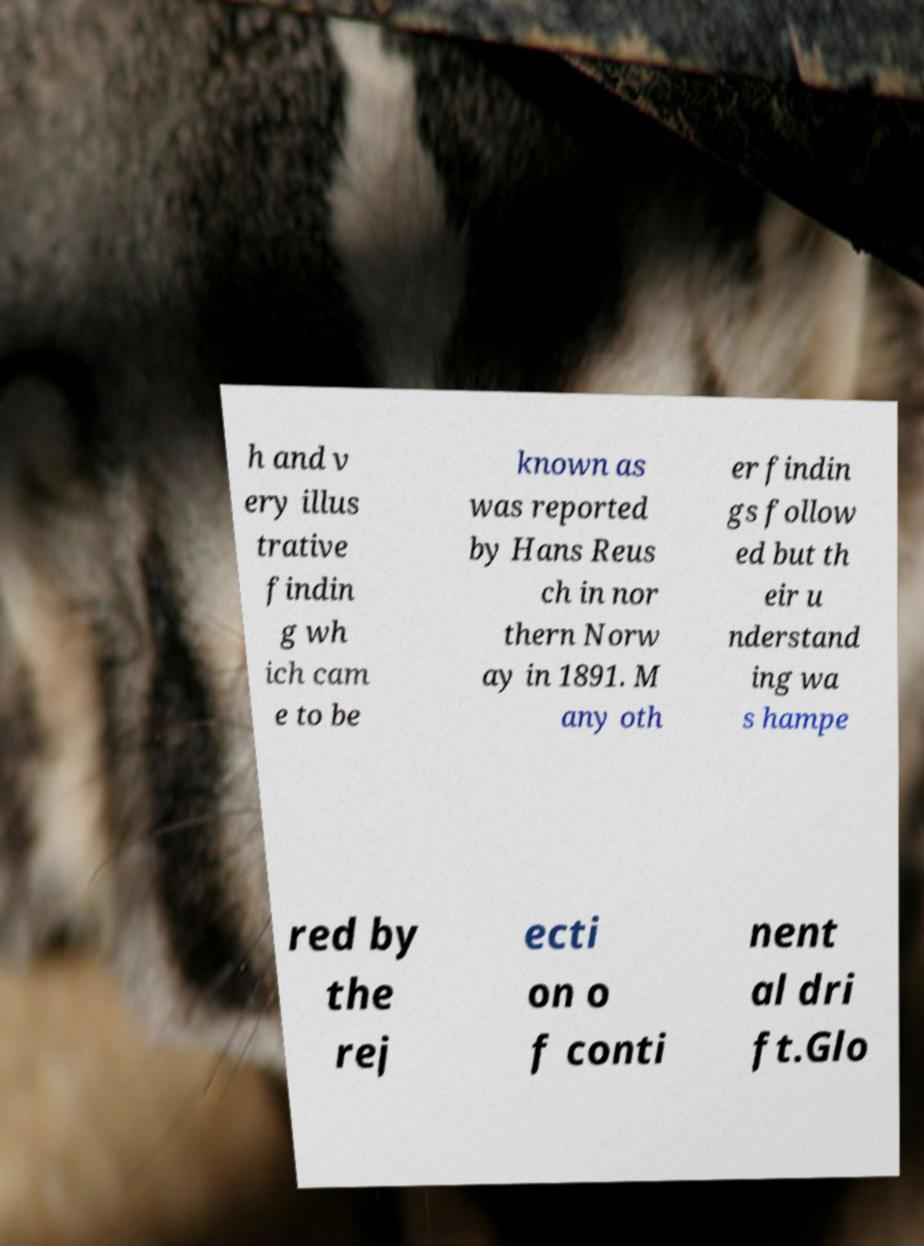Could you extract and type out the text from this image? h and v ery illus trative findin g wh ich cam e to be known as was reported by Hans Reus ch in nor thern Norw ay in 1891. M any oth er findin gs follow ed but th eir u nderstand ing wa s hampe red by the rej ecti on o f conti nent al dri ft.Glo 